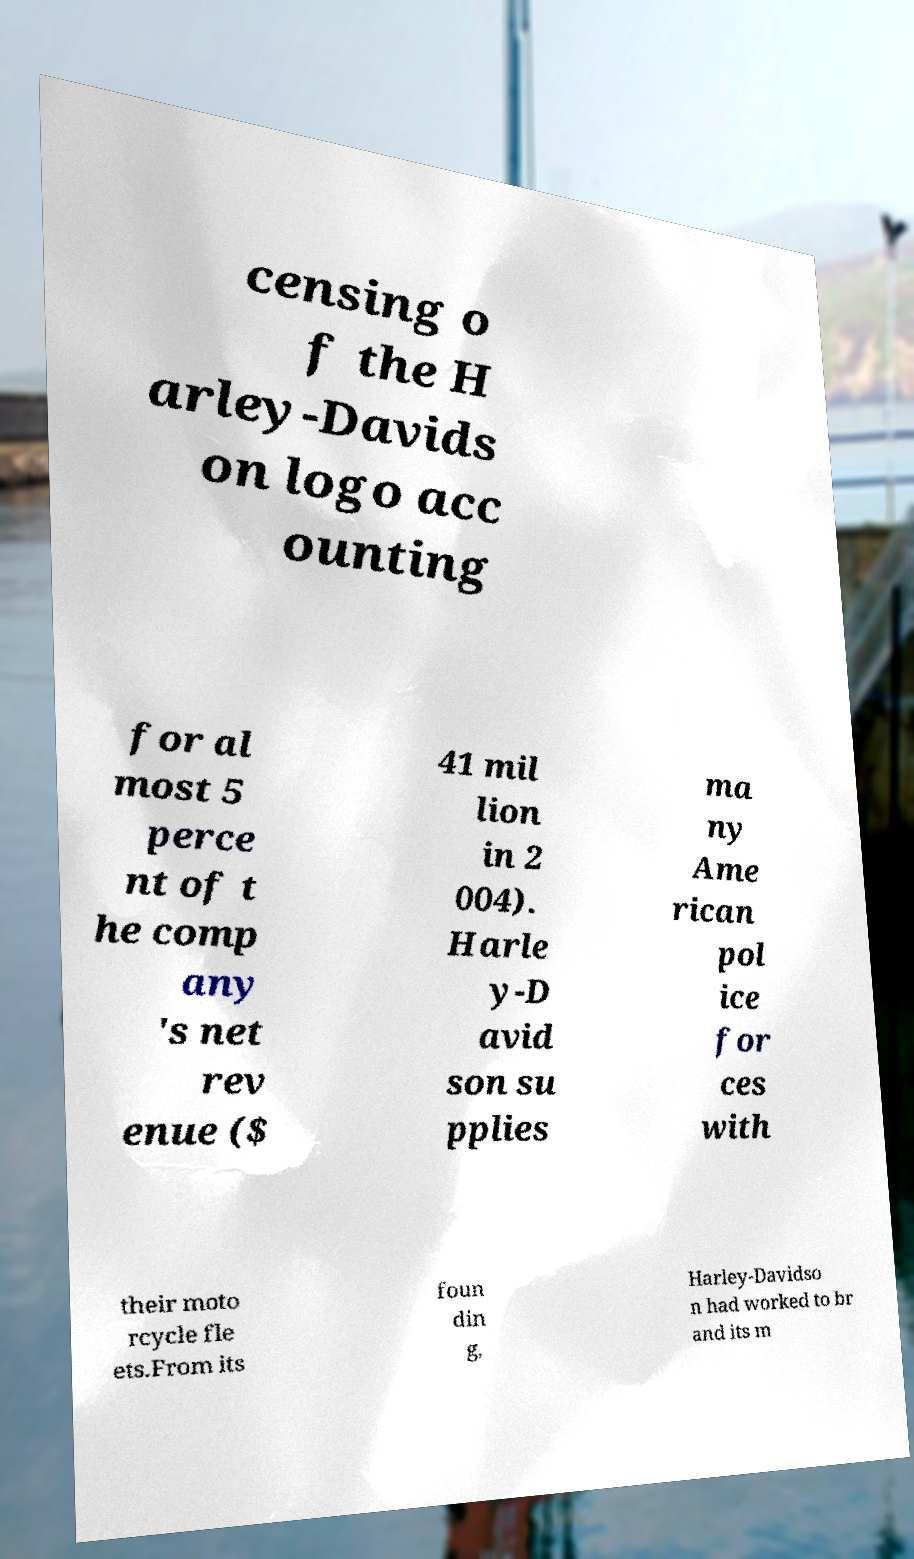What messages or text are displayed in this image? I need them in a readable, typed format. censing o f the H arley-Davids on logo acc ounting for al most 5 perce nt of t he comp any 's net rev enue ($ 41 mil lion in 2 004). Harle y-D avid son su pplies ma ny Ame rican pol ice for ces with their moto rcycle fle ets.From its foun din g, Harley-Davidso n had worked to br and its m 